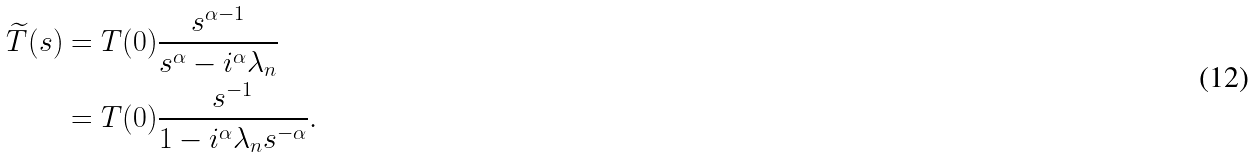Convert formula to latex. <formula><loc_0><loc_0><loc_500><loc_500>\widetilde { T } ( s ) & = T ( 0 ) \frac { s ^ { \alpha - 1 } } { s ^ { \alpha } - i ^ { \alpha } \lambda _ { n } } \ \\ & = T ( 0 ) \frac { s ^ { - 1 } } { 1 - i ^ { \alpha } \lambda _ { n } s ^ { - \alpha } } .</formula> 